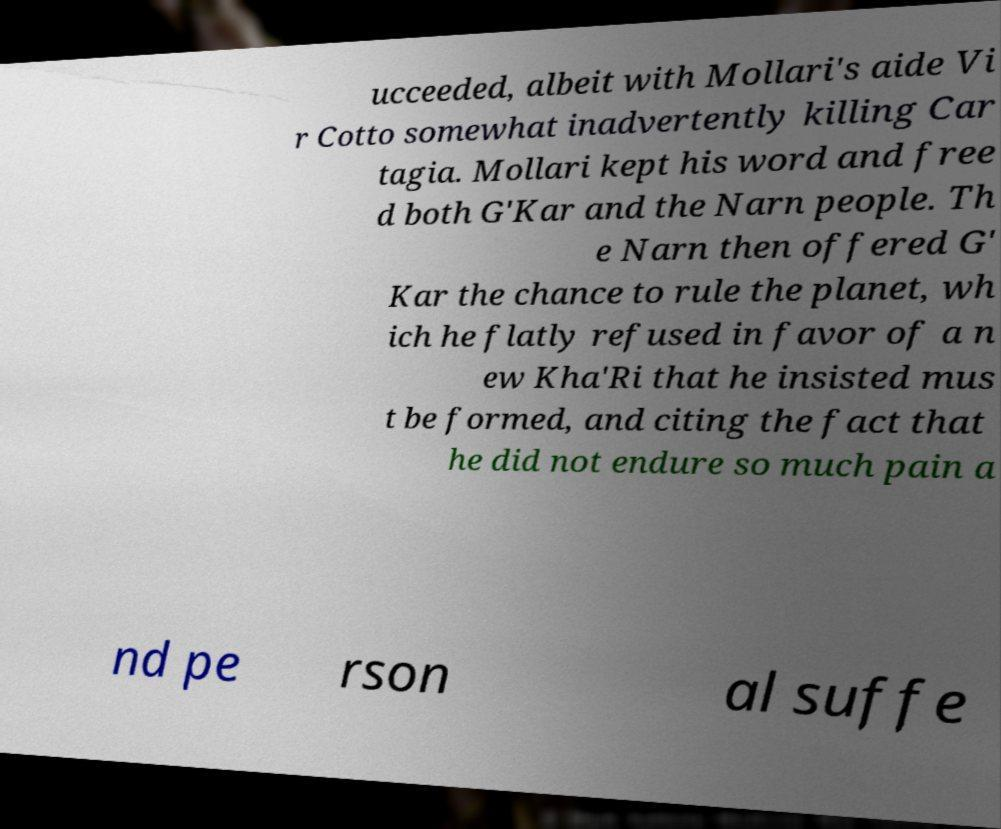There's text embedded in this image that I need extracted. Can you transcribe it verbatim? ucceeded, albeit with Mollari's aide Vi r Cotto somewhat inadvertently killing Car tagia. Mollari kept his word and free d both G'Kar and the Narn people. Th e Narn then offered G' Kar the chance to rule the planet, wh ich he flatly refused in favor of a n ew Kha'Ri that he insisted mus t be formed, and citing the fact that he did not endure so much pain a nd pe rson al suffe 